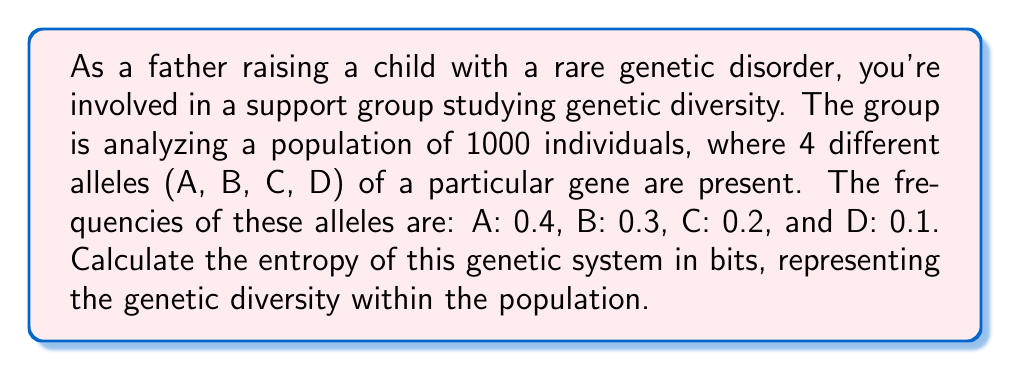Solve this math problem. To calculate the entropy of this genetic system, we'll use the Shannon entropy formula, which is applicable to discrete probability distributions:

$$S = -\sum_{i} p_i \log_2(p_i)$$

Where $S$ is the entropy, and $p_i$ is the probability (or frequency) of each allele.

Step 1: Identify the probabilities (frequencies) for each allele:
$p_A = 0.4$
$p_B = 0.3$
$p_C = 0.2$
$p_D = 0.1$

Step 2: Calculate the entropy contribution of each allele:

For A: $-0.4 \log_2(0.4) = 0.528321$
For B: $-0.3 \log_2(0.3) = 0.521436$
For C: $-0.2 \log_2(0.2) = 0.464386$
For D: $-0.1 \log_2(0.1) = 0.332193$

Step 3: Sum up all the contributions:

$$S = 0.528321 + 0.521436 + 0.464386 + 0.332193 = 1.846336$$

Therefore, the entropy of the genetic system is approximately 1.85 bits.
Answer: 1.85 bits 